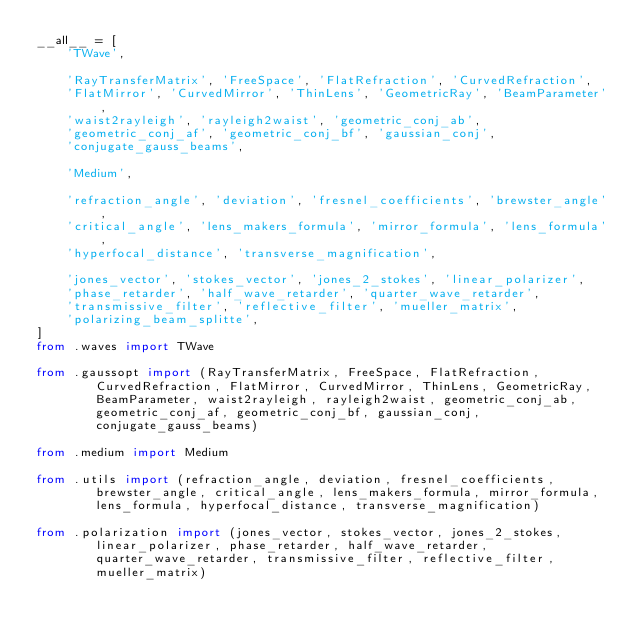<code> <loc_0><loc_0><loc_500><loc_500><_Python_>__all__ = [
    'TWave',

    'RayTransferMatrix', 'FreeSpace', 'FlatRefraction', 'CurvedRefraction',
    'FlatMirror', 'CurvedMirror', 'ThinLens', 'GeometricRay', 'BeamParameter',
    'waist2rayleigh', 'rayleigh2waist', 'geometric_conj_ab',
    'geometric_conj_af', 'geometric_conj_bf', 'gaussian_conj',
    'conjugate_gauss_beams',

    'Medium',

    'refraction_angle', 'deviation', 'fresnel_coefficients', 'brewster_angle',
    'critical_angle', 'lens_makers_formula', 'mirror_formula', 'lens_formula',
    'hyperfocal_distance', 'transverse_magnification',

    'jones_vector', 'stokes_vector', 'jones_2_stokes', 'linear_polarizer',
    'phase_retarder', 'half_wave_retarder', 'quarter_wave_retarder',
    'transmissive_filter', 'reflective_filter', 'mueller_matrix',
    'polarizing_beam_splitte',
]
from .waves import TWave

from .gaussopt import (RayTransferMatrix, FreeSpace, FlatRefraction,
        CurvedRefraction, FlatMirror, CurvedMirror, ThinLens, GeometricRay,
        BeamParameter, waist2rayleigh, rayleigh2waist, geometric_conj_ab,
        geometric_conj_af, geometric_conj_bf, gaussian_conj,
        conjugate_gauss_beams)

from .medium import Medium

from .utils import (refraction_angle, deviation, fresnel_coefficients,
        brewster_angle, critical_angle, lens_makers_formula, mirror_formula,
        lens_formula, hyperfocal_distance, transverse_magnification)

from .polarization import (jones_vector, stokes_vector, jones_2_stokes,
        linear_polarizer, phase_retarder, half_wave_retarder,
        quarter_wave_retarder, transmissive_filter, reflective_filter,
        mueller_matrix)
</code> 